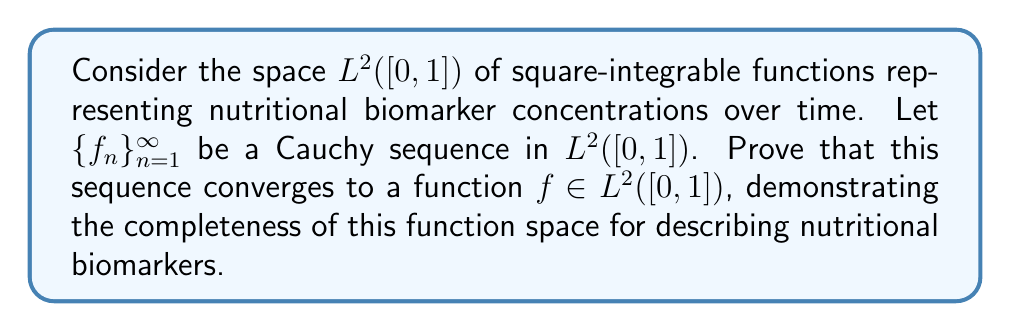Can you solve this math problem? To prove the completeness of $L^2([0,1])$, we need to show that every Cauchy sequence in this space converges to an element within the space. Let's approach this step-by-step:

1) First, recall that a sequence $\{f_n\}_{n=1}^{\infty}$ is Cauchy in $L^2([0,1])$ if for every $\epsilon > 0$, there exists an $N \in \mathbb{N}$ such that for all $m, n \geq N$:

   $$\|f_m - f_n\|_2 < \epsilon$$

   where $\|\cdot\|_2$ denotes the $L^2$ norm.

2) By the definition of the $L^2$ norm:

   $$\|f_m - f_n\|_2^2 = \int_0^1 |f_m(t) - f_n(t)|^2 dt < \epsilon^2$$

3) Now, we can use a theorem from real analysis: if a sequence of functions converges in $L^2$ norm, then there exists a subsequence that converges pointwise almost everywhere.

4) Let $\{f_{n_k}\}_{k=1}^{\infty}$ be this subsequence that converges pointwise almost everywhere to some function $f$. That is, for almost all $t \in [0,1]$:

   $$\lim_{k \to \infty} f_{n_k}(t) = f(t)$$

5) We now need to show that $f \in L^2([0,1])$ and that the original sequence $\{f_n\}_{n=1}^{\infty}$ converges to $f$ in $L^2$ norm.

6) To show $f \in L^2([0,1])$, we can use Fatou's lemma:

   $$\int_0^1 |f(t)|^2 dt \leq \liminf_{k \to \infty} \int_0^1 |f_{n_k}(t)|^2 dt < \infty$$

   The last inequality holds because each $f_{n_k}$ is in $L^2([0,1])$.

7) To show that $\{f_n\}_{n=1}^{\infty}$ converges to $f$ in $L^2$ norm, we can use the triangle inequality:

   $$\|f_n - f\|_2 \leq \|f_n - f_m\|_2 + \|f_m - f\|_2$$

8) For any $\epsilon > 0$, we can choose $m$ large enough so that $\|f_n - f_m\|_2 < \epsilon/2$ for all $n \geq m$ (since $\{f_n\}$ is Cauchy).

9) Then, we can show that $\|f_m - f\|_2 \to 0$ as $m \to \infty$ using the dominated convergence theorem.

10) Combining these results, we can conclude that $\|f_n - f\|_2 \to 0$ as $n \to \infty$.

Therefore, we have shown that the Cauchy sequence $\{f_n\}_{n=1}^{\infty}$ converges to $f \in L^2([0,1])$, proving the completeness of $L^2([0,1])$.
Answer: The space $L^2([0,1])$ is complete. Every Cauchy sequence $\{f_n\}_{n=1}^{\infty}$ in $L^2([0,1])$ converges to a function $f \in L^2([0,1])$ in the $L^2$ norm. 